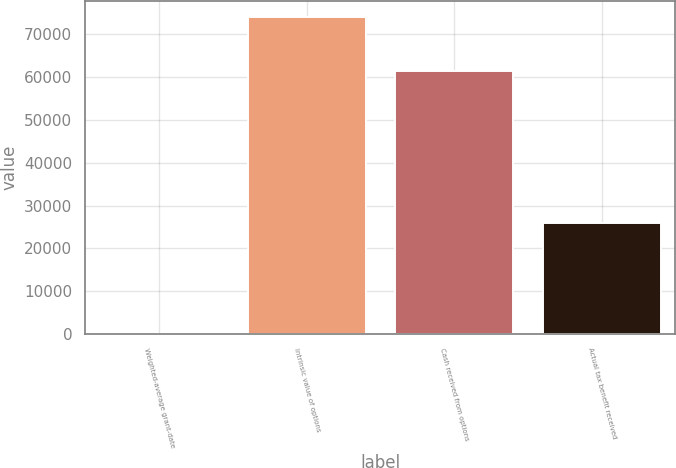Convert chart. <chart><loc_0><loc_0><loc_500><loc_500><bar_chart><fcel>Weighted-average grant-date<fcel>Intrinsic value of options<fcel>Cash received from options<fcel>Actual tax benefit received<nl><fcel>9.04<fcel>73995<fcel>61329<fcel>25898<nl></chart> 